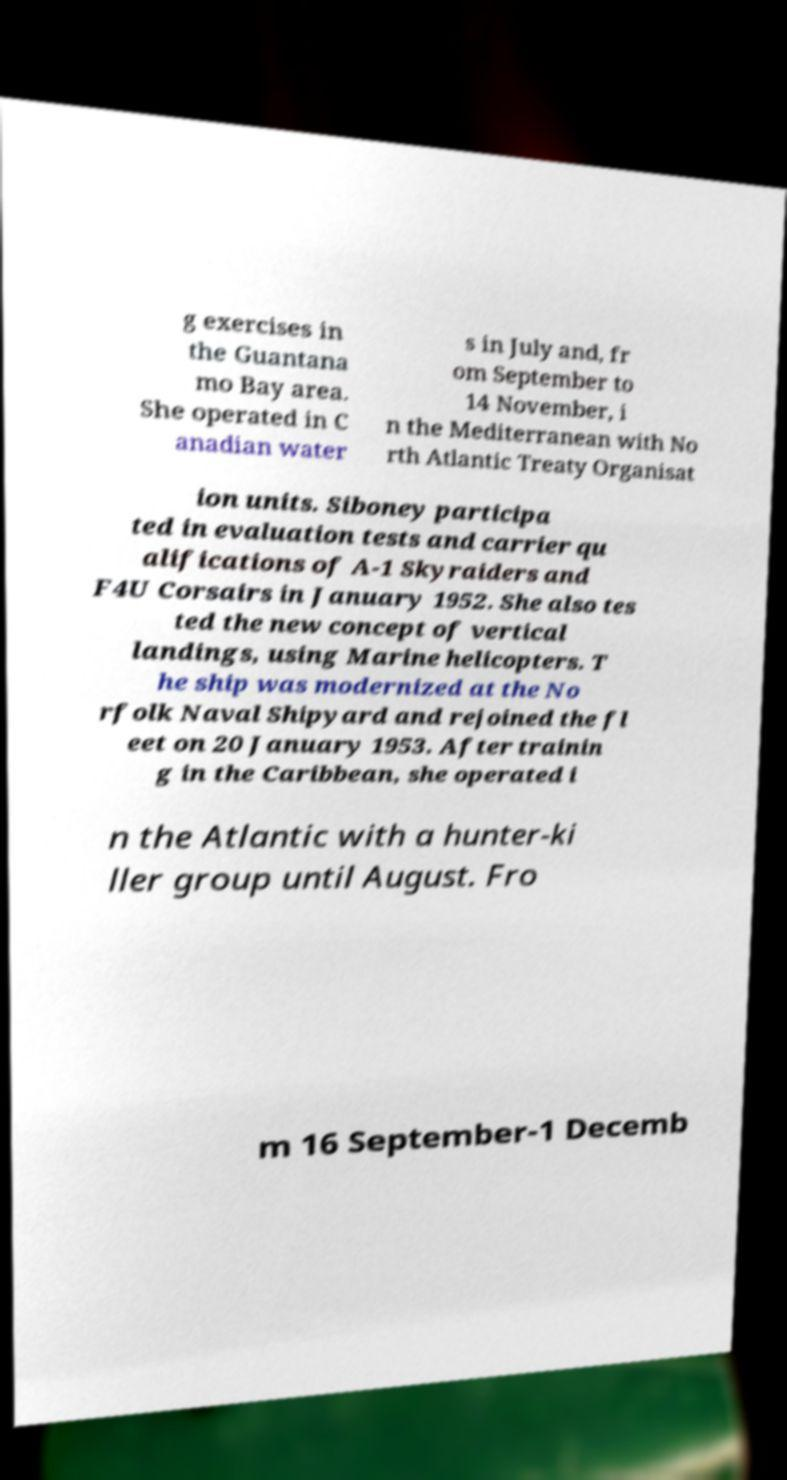Could you extract and type out the text from this image? g exercises in the Guantana mo Bay area. She operated in C anadian water s in July and, fr om September to 14 November, i n the Mediterranean with No rth Atlantic Treaty Organisat ion units. Siboney participa ted in evaluation tests and carrier qu alifications of A-1 Skyraiders and F4U Corsairs in January 1952. She also tes ted the new concept of vertical landings, using Marine helicopters. T he ship was modernized at the No rfolk Naval Shipyard and rejoined the fl eet on 20 January 1953. After trainin g in the Caribbean, she operated i n the Atlantic with a hunter-ki ller group until August. Fro m 16 September-1 Decemb 